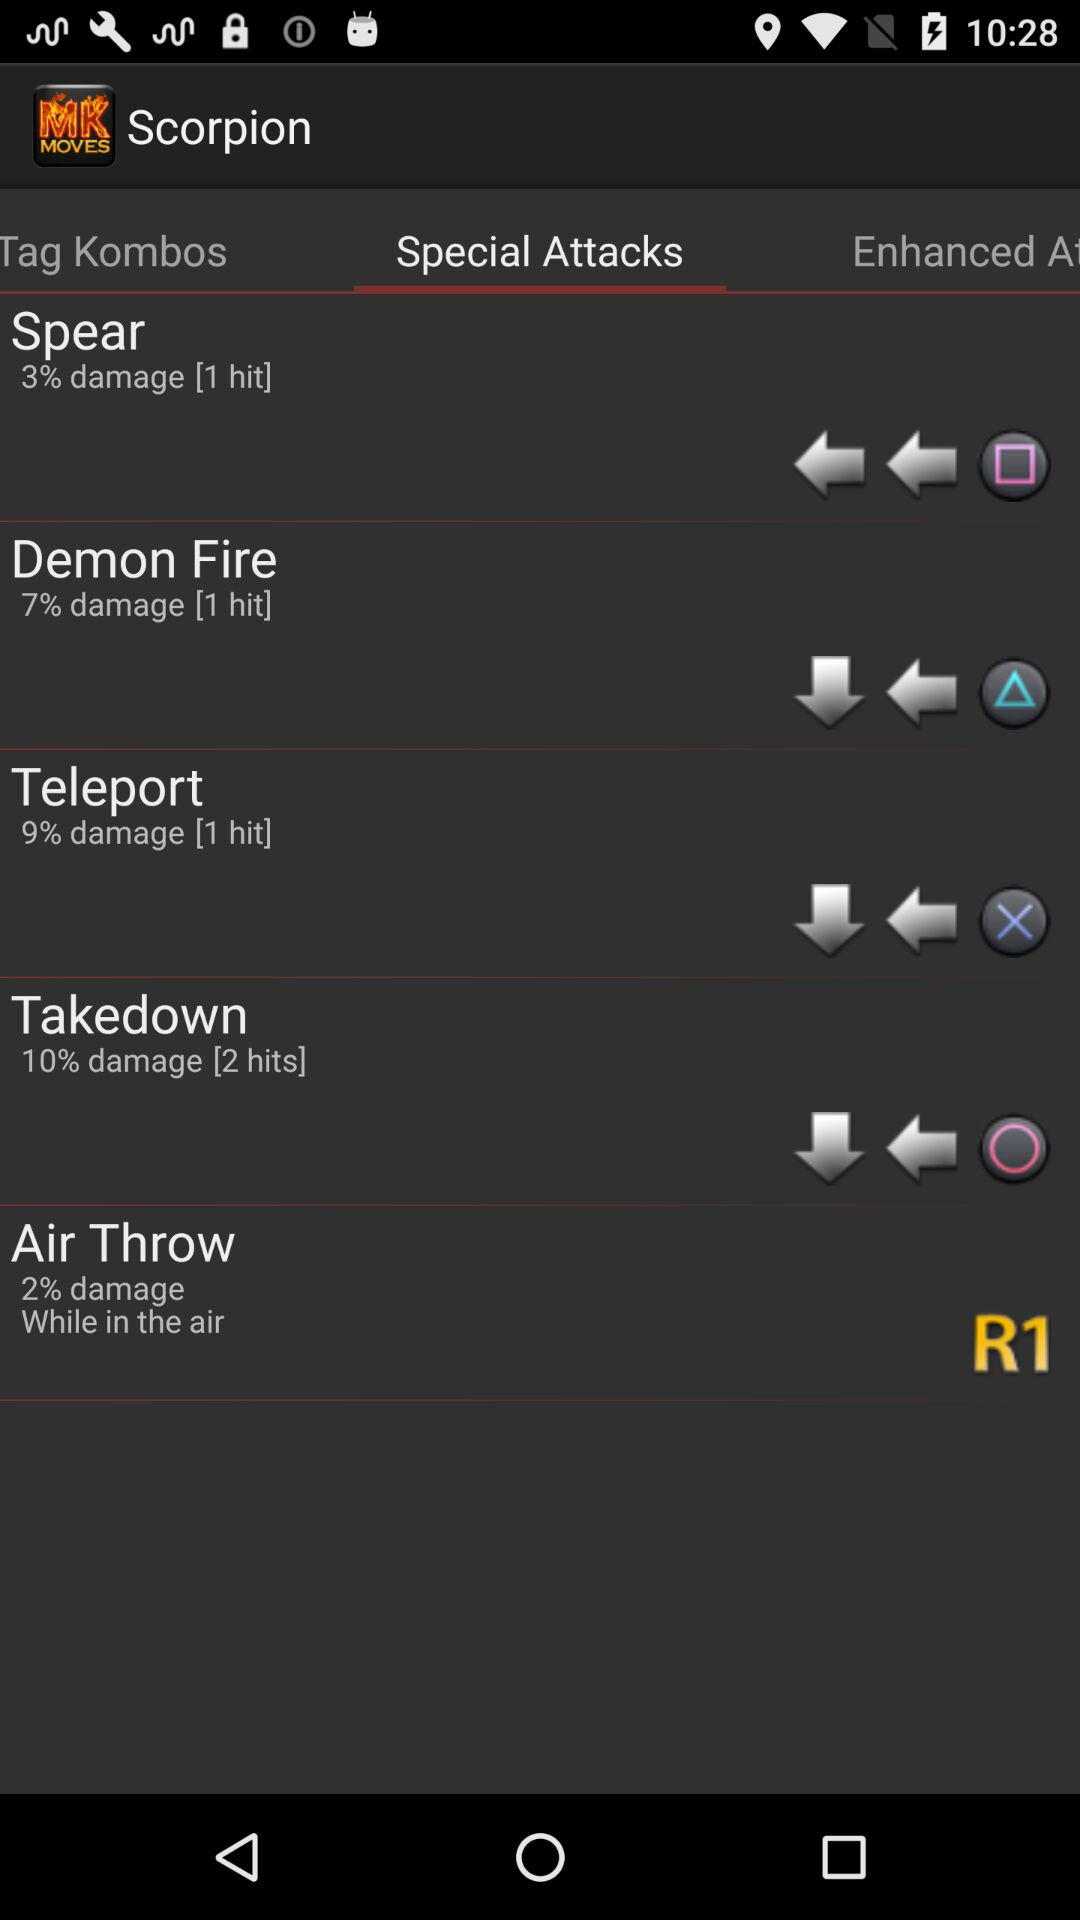How many hits does Takedown do?
Answer the question using a single word or phrase. 2 